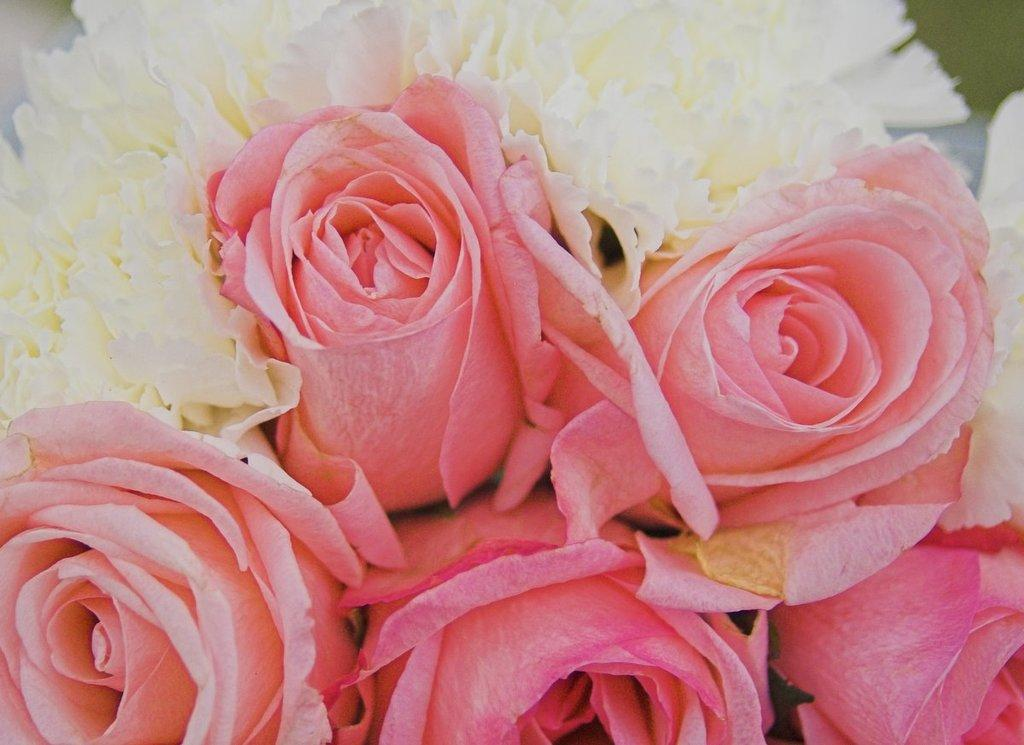What types of plants are in the image? There are different types of flowers in the image. How are the flowers arranged in the image? The flowers are arranged in a bunch. Where can the squirrel be seen playing with toys in the image? There is no squirrel or toys present in the image. 